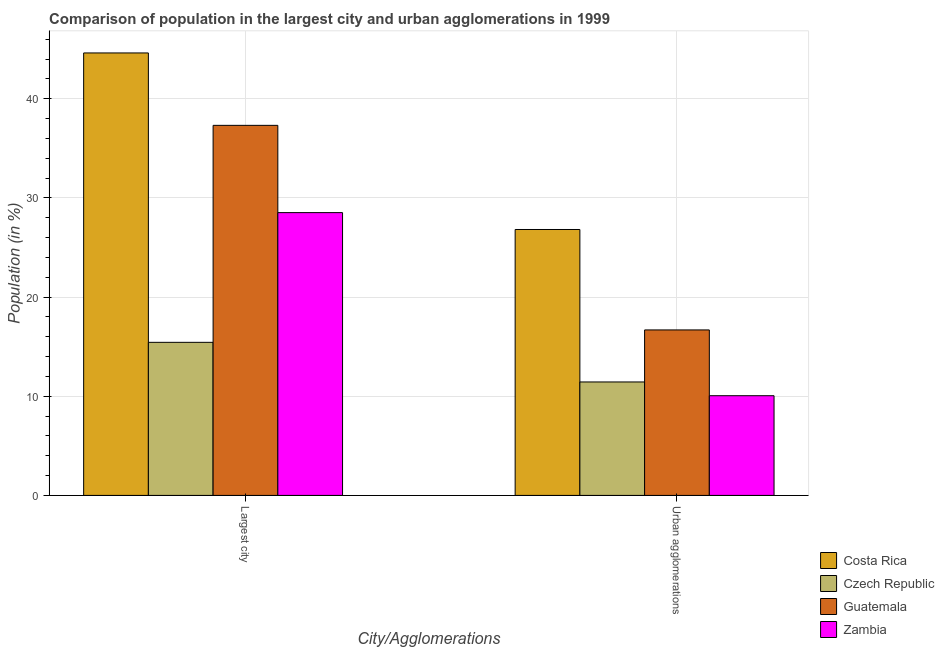How many different coloured bars are there?
Keep it short and to the point. 4. Are the number of bars per tick equal to the number of legend labels?
Your answer should be compact. Yes. Are the number of bars on each tick of the X-axis equal?
Your answer should be compact. Yes. How many bars are there on the 2nd tick from the right?
Your response must be concise. 4. What is the label of the 2nd group of bars from the left?
Provide a short and direct response. Urban agglomerations. What is the population in urban agglomerations in Zambia?
Keep it short and to the point. 10.05. Across all countries, what is the maximum population in urban agglomerations?
Make the answer very short. 26.81. Across all countries, what is the minimum population in the largest city?
Give a very brief answer. 15.43. In which country was the population in the largest city maximum?
Provide a succinct answer. Costa Rica. In which country was the population in the largest city minimum?
Give a very brief answer. Czech Republic. What is the total population in the largest city in the graph?
Offer a very short reply. 125.88. What is the difference between the population in urban agglomerations in Czech Republic and that in Guatemala?
Make the answer very short. -5.25. What is the difference between the population in the largest city in Costa Rica and the population in urban agglomerations in Guatemala?
Your answer should be compact. 27.93. What is the average population in urban agglomerations per country?
Provide a succinct answer. 16.25. What is the difference between the population in the largest city and population in urban agglomerations in Czech Republic?
Make the answer very short. 3.99. What is the ratio of the population in urban agglomerations in Zambia to that in Guatemala?
Your answer should be very brief. 0.6. Is the population in the largest city in Guatemala less than that in Costa Rica?
Offer a terse response. Yes. In how many countries, is the population in urban agglomerations greater than the average population in urban agglomerations taken over all countries?
Your answer should be compact. 2. What does the 4th bar from the left in Urban agglomerations represents?
Your response must be concise. Zambia. What does the 3rd bar from the right in Urban agglomerations represents?
Your response must be concise. Czech Republic. How many bars are there?
Ensure brevity in your answer.  8. Are all the bars in the graph horizontal?
Ensure brevity in your answer.  No. Does the graph contain any zero values?
Ensure brevity in your answer.  No. Where does the legend appear in the graph?
Make the answer very short. Bottom right. How many legend labels are there?
Offer a terse response. 4. How are the legend labels stacked?
Ensure brevity in your answer.  Vertical. What is the title of the graph?
Provide a short and direct response. Comparison of population in the largest city and urban agglomerations in 1999. What is the label or title of the X-axis?
Provide a succinct answer. City/Agglomerations. What is the Population (in %) in Costa Rica in Largest city?
Offer a terse response. 44.61. What is the Population (in %) in Czech Republic in Largest city?
Your response must be concise. 15.43. What is the Population (in %) of Guatemala in Largest city?
Make the answer very short. 37.31. What is the Population (in %) of Zambia in Largest city?
Give a very brief answer. 28.52. What is the Population (in %) of Costa Rica in Urban agglomerations?
Your answer should be compact. 26.81. What is the Population (in %) of Czech Republic in Urban agglomerations?
Provide a short and direct response. 11.44. What is the Population (in %) of Guatemala in Urban agglomerations?
Provide a succinct answer. 16.69. What is the Population (in %) in Zambia in Urban agglomerations?
Ensure brevity in your answer.  10.05. Across all City/Agglomerations, what is the maximum Population (in %) of Costa Rica?
Ensure brevity in your answer.  44.61. Across all City/Agglomerations, what is the maximum Population (in %) in Czech Republic?
Keep it short and to the point. 15.43. Across all City/Agglomerations, what is the maximum Population (in %) of Guatemala?
Provide a succinct answer. 37.31. Across all City/Agglomerations, what is the maximum Population (in %) of Zambia?
Provide a short and direct response. 28.52. Across all City/Agglomerations, what is the minimum Population (in %) in Costa Rica?
Provide a short and direct response. 26.81. Across all City/Agglomerations, what is the minimum Population (in %) of Czech Republic?
Your answer should be very brief. 11.44. Across all City/Agglomerations, what is the minimum Population (in %) in Guatemala?
Provide a short and direct response. 16.69. Across all City/Agglomerations, what is the minimum Population (in %) in Zambia?
Offer a terse response. 10.05. What is the total Population (in %) of Costa Rica in the graph?
Offer a terse response. 71.43. What is the total Population (in %) of Czech Republic in the graph?
Your answer should be very brief. 26.88. What is the total Population (in %) of Guatemala in the graph?
Offer a terse response. 54. What is the total Population (in %) in Zambia in the graph?
Your response must be concise. 38.57. What is the difference between the Population (in %) in Costa Rica in Largest city and that in Urban agglomerations?
Ensure brevity in your answer.  17.8. What is the difference between the Population (in %) of Czech Republic in Largest city and that in Urban agglomerations?
Make the answer very short. 3.99. What is the difference between the Population (in %) in Guatemala in Largest city and that in Urban agglomerations?
Give a very brief answer. 20.63. What is the difference between the Population (in %) in Zambia in Largest city and that in Urban agglomerations?
Keep it short and to the point. 18.46. What is the difference between the Population (in %) of Costa Rica in Largest city and the Population (in %) of Czech Republic in Urban agglomerations?
Offer a terse response. 33.17. What is the difference between the Population (in %) of Costa Rica in Largest city and the Population (in %) of Guatemala in Urban agglomerations?
Your answer should be very brief. 27.93. What is the difference between the Population (in %) of Costa Rica in Largest city and the Population (in %) of Zambia in Urban agglomerations?
Your response must be concise. 34.56. What is the difference between the Population (in %) of Czech Republic in Largest city and the Population (in %) of Guatemala in Urban agglomerations?
Make the answer very short. -1.25. What is the difference between the Population (in %) in Czech Republic in Largest city and the Population (in %) in Zambia in Urban agglomerations?
Offer a very short reply. 5.38. What is the difference between the Population (in %) of Guatemala in Largest city and the Population (in %) of Zambia in Urban agglomerations?
Make the answer very short. 27.26. What is the average Population (in %) in Costa Rica per City/Agglomerations?
Ensure brevity in your answer.  35.71. What is the average Population (in %) in Czech Republic per City/Agglomerations?
Your response must be concise. 13.44. What is the average Population (in %) of Guatemala per City/Agglomerations?
Your answer should be very brief. 27. What is the average Population (in %) in Zambia per City/Agglomerations?
Your answer should be compact. 19.28. What is the difference between the Population (in %) of Costa Rica and Population (in %) of Czech Republic in Largest city?
Offer a terse response. 29.18. What is the difference between the Population (in %) of Costa Rica and Population (in %) of Guatemala in Largest city?
Give a very brief answer. 7.3. What is the difference between the Population (in %) in Costa Rica and Population (in %) in Zambia in Largest city?
Offer a terse response. 16.1. What is the difference between the Population (in %) in Czech Republic and Population (in %) in Guatemala in Largest city?
Your response must be concise. -21.88. What is the difference between the Population (in %) in Czech Republic and Population (in %) in Zambia in Largest city?
Provide a short and direct response. -13.08. What is the difference between the Population (in %) of Guatemala and Population (in %) of Zambia in Largest city?
Make the answer very short. 8.8. What is the difference between the Population (in %) in Costa Rica and Population (in %) in Czech Republic in Urban agglomerations?
Provide a succinct answer. 15.37. What is the difference between the Population (in %) of Costa Rica and Population (in %) of Guatemala in Urban agglomerations?
Your answer should be compact. 10.13. What is the difference between the Population (in %) in Costa Rica and Population (in %) in Zambia in Urban agglomerations?
Your answer should be very brief. 16.76. What is the difference between the Population (in %) in Czech Republic and Population (in %) in Guatemala in Urban agglomerations?
Your answer should be compact. -5.25. What is the difference between the Population (in %) in Czech Republic and Population (in %) in Zambia in Urban agglomerations?
Your answer should be compact. 1.39. What is the difference between the Population (in %) of Guatemala and Population (in %) of Zambia in Urban agglomerations?
Your response must be concise. 6.63. What is the ratio of the Population (in %) in Costa Rica in Largest city to that in Urban agglomerations?
Keep it short and to the point. 1.66. What is the ratio of the Population (in %) in Czech Republic in Largest city to that in Urban agglomerations?
Offer a very short reply. 1.35. What is the ratio of the Population (in %) in Guatemala in Largest city to that in Urban agglomerations?
Your answer should be compact. 2.24. What is the ratio of the Population (in %) in Zambia in Largest city to that in Urban agglomerations?
Offer a very short reply. 2.84. What is the difference between the highest and the second highest Population (in %) in Costa Rica?
Make the answer very short. 17.8. What is the difference between the highest and the second highest Population (in %) of Czech Republic?
Your answer should be very brief. 3.99. What is the difference between the highest and the second highest Population (in %) of Guatemala?
Your answer should be very brief. 20.63. What is the difference between the highest and the second highest Population (in %) of Zambia?
Make the answer very short. 18.46. What is the difference between the highest and the lowest Population (in %) of Costa Rica?
Provide a short and direct response. 17.8. What is the difference between the highest and the lowest Population (in %) in Czech Republic?
Your response must be concise. 3.99. What is the difference between the highest and the lowest Population (in %) of Guatemala?
Offer a terse response. 20.63. What is the difference between the highest and the lowest Population (in %) of Zambia?
Provide a short and direct response. 18.46. 